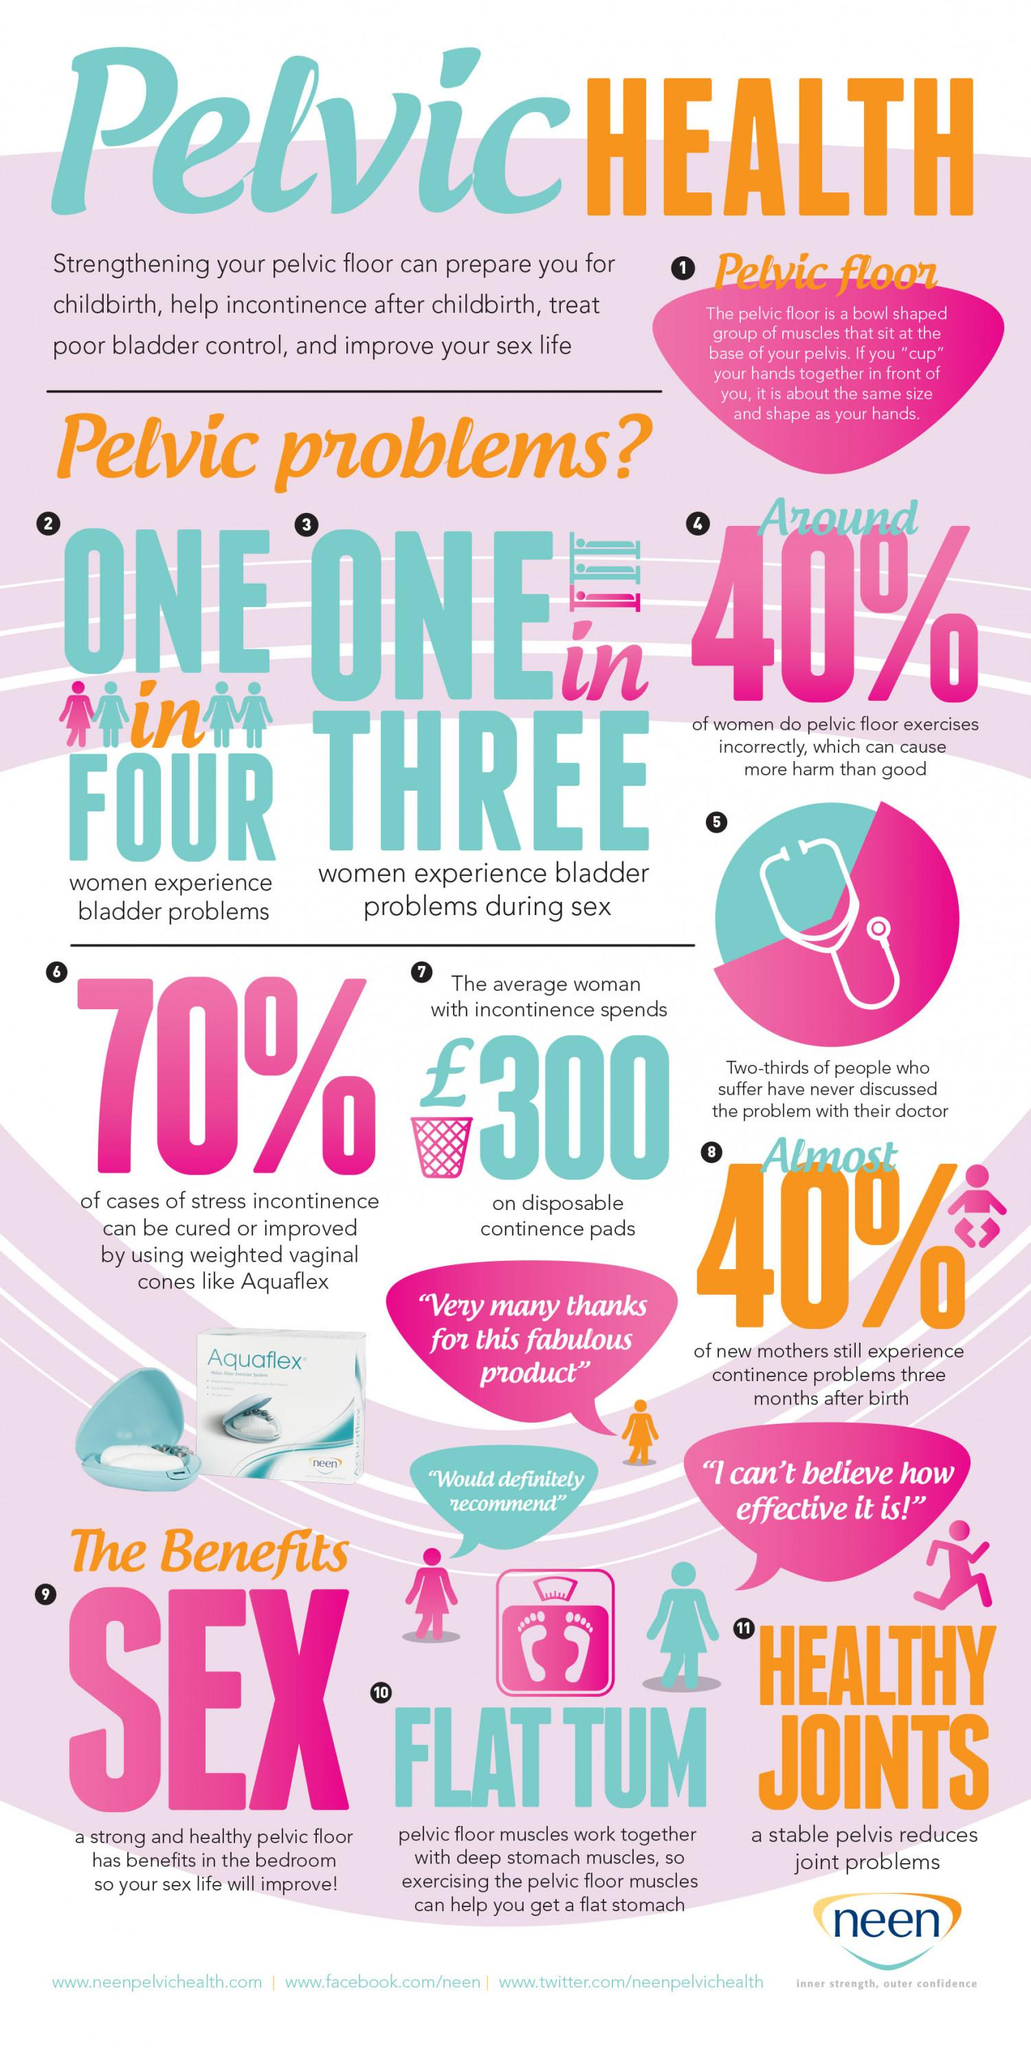Highlight a few significant elements in this photo. Pelvic floor exercises have several advantages, including improved sexual function, flatter tummies, and healthier joints. It is estimated that one in four women experience urinary bladder issues. The number of advantages of pelvic floor exercises listed is three. Studies show that one in three women experience issues with sex due to bladder problems. 